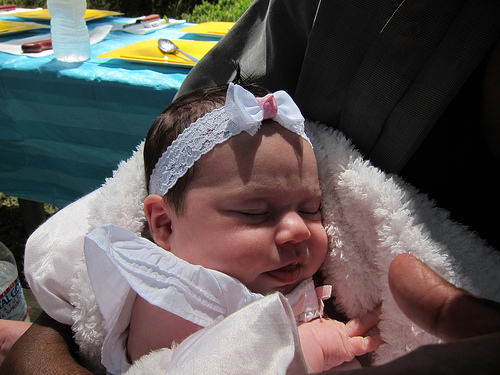<image>
Is the women on the baby? No. The women is not positioned on the baby. They may be near each other, but the women is not supported by or resting on top of the baby. 